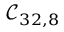<formula> <loc_0><loc_0><loc_500><loc_500>\mathcal { C } _ { 3 2 , 8 }</formula> 